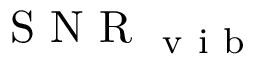Convert formula to latex. <formula><loc_0><loc_0><loc_500><loc_500>S N R _ { v i b }</formula> 